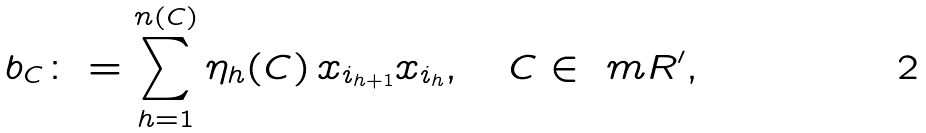Convert formula to latex. <formula><loc_0><loc_0><loc_500><loc_500>b _ { C } \colon & = \sum _ { h = 1 } ^ { n ( C ) } \eta _ { h } ( C ) \, x _ { i _ { h + 1 } } x _ { i _ { h } } , \quad C \in \ m R ^ { \prime } ,</formula> 